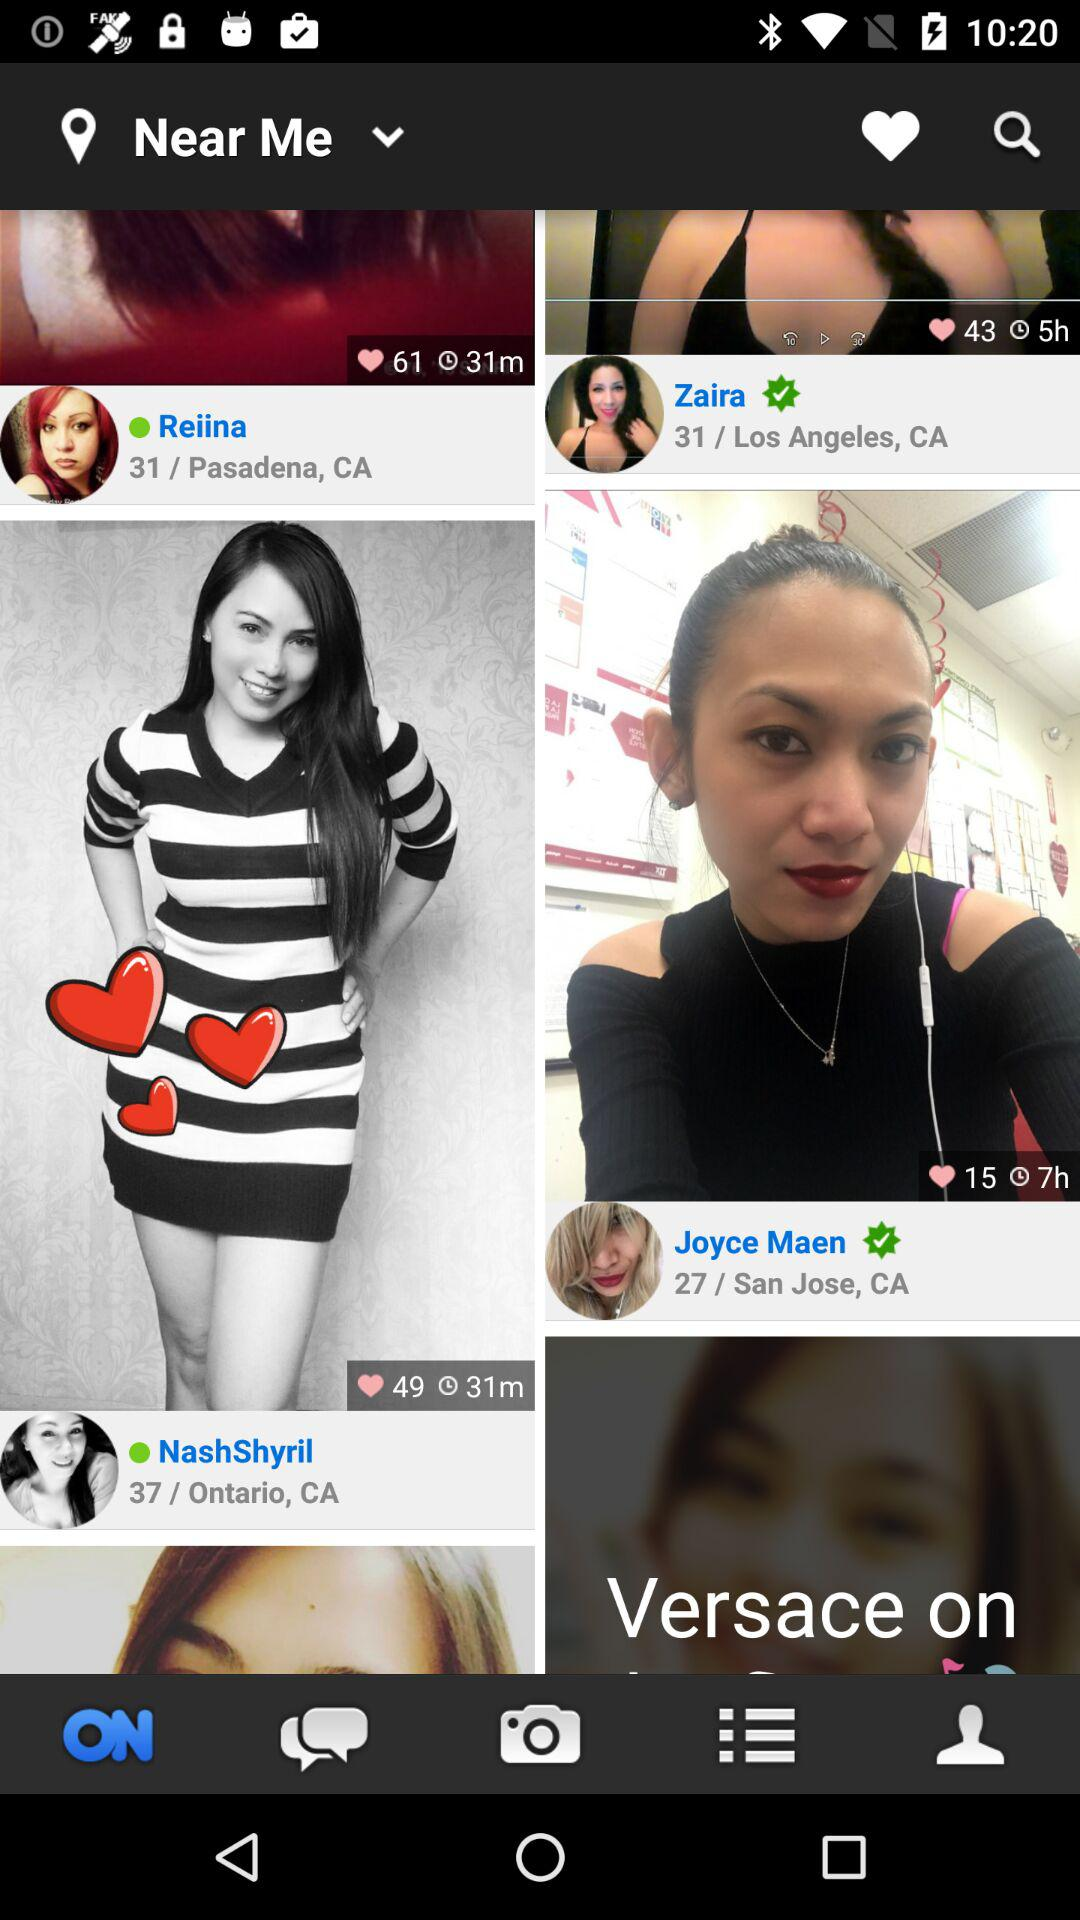NashShyril belongs to what city? NashShyril belongs to Ontario, CA. 